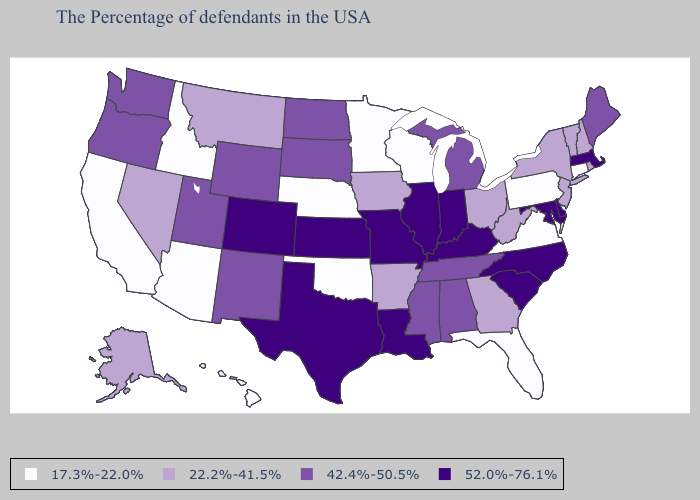What is the value of West Virginia?
Quick response, please. 22.2%-41.5%. Does Indiana have the same value as Arkansas?
Concise answer only. No. How many symbols are there in the legend?
Short answer required. 4. Name the states that have a value in the range 52.0%-76.1%?
Keep it brief. Massachusetts, Delaware, Maryland, North Carolina, South Carolina, Kentucky, Indiana, Illinois, Louisiana, Missouri, Kansas, Texas, Colorado. How many symbols are there in the legend?
Short answer required. 4. What is the lowest value in the MidWest?
Write a very short answer. 17.3%-22.0%. Which states have the highest value in the USA?
Write a very short answer. Massachusetts, Delaware, Maryland, North Carolina, South Carolina, Kentucky, Indiana, Illinois, Louisiana, Missouri, Kansas, Texas, Colorado. Does Colorado have the highest value in the West?
Answer briefly. Yes. Name the states that have a value in the range 52.0%-76.1%?
Keep it brief. Massachusetts, Delaware, Maryland, North Carolina, South Carolina, Kentucky, Indiana, Illinois, Louisiana, Missouri, Kansas, Texas, Colorado. What is the lowest value in the West?
Quick response, please. 17.3%-22.0%. What is the highest value in the West ?
Answer briefly. 52.0%-76.1%. Does the first symbol in the legend represent the smallest category?
Short answer required. Yes. What is the value of Texas?
Concise answer only. 52.0%-76.1%. Which states hav the highest value in the West?
Short answer required. Colorado. Which states have the lowest value in the USA?
Be succinct. Connecticut, Pennsylvania, Virginia, Florida, Wisconsin, Minnesota, Nebraska, Oklahoma, Arizona, Idaho, California, Hawaii. 